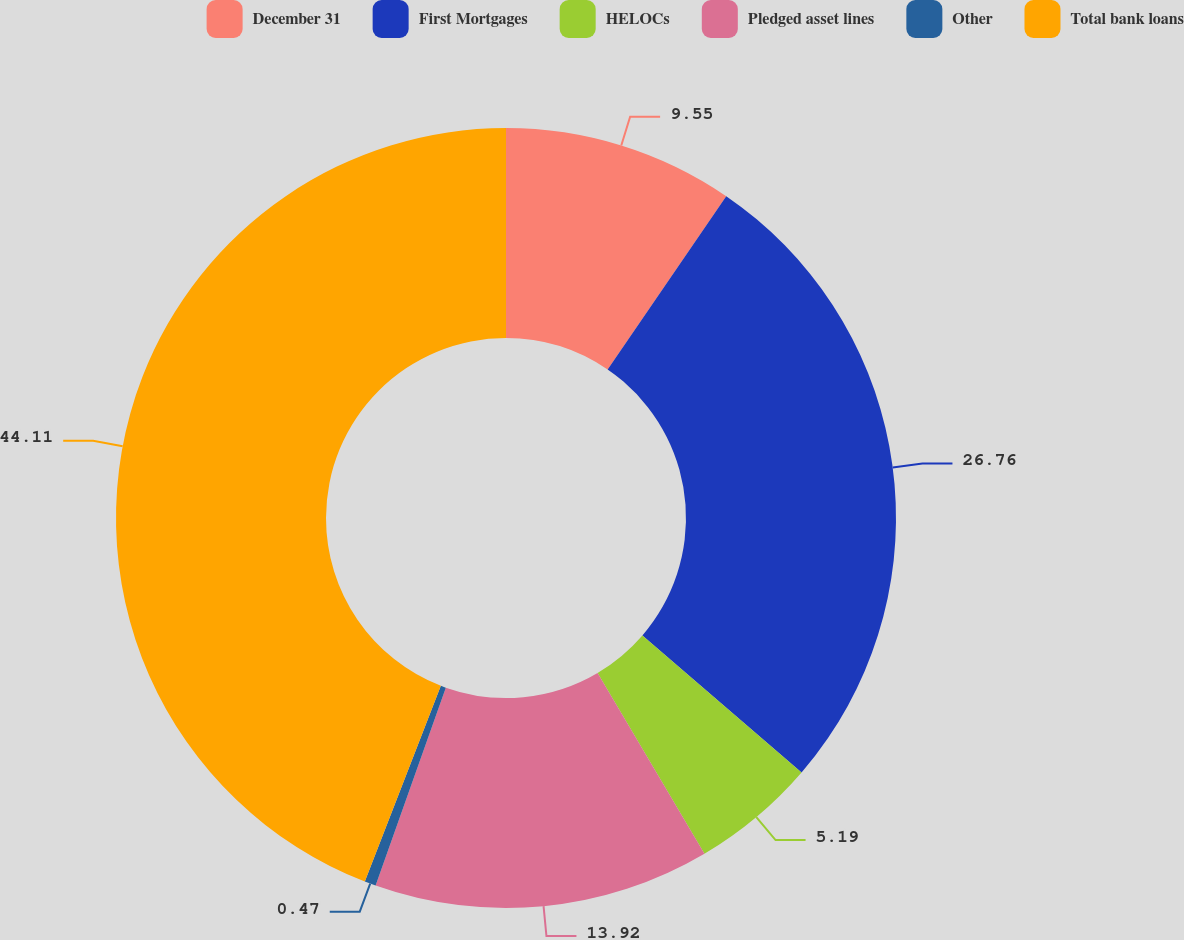Convert chart to OTSL. <chart><loc_0><loc_0><loc_500><loc_500><pie_chart><fcel>December 31<fcel>First Mortgages<fcel>HELOCs<fcel>Pledged asset lines<fcel>Other<fcel>Total bank loans<nl><fcel>9.55%<fcel>26.76%<fcel>5.19%<fcel>13.92%<fcel>0.47%<fcel>44.1%<nl></chart> 